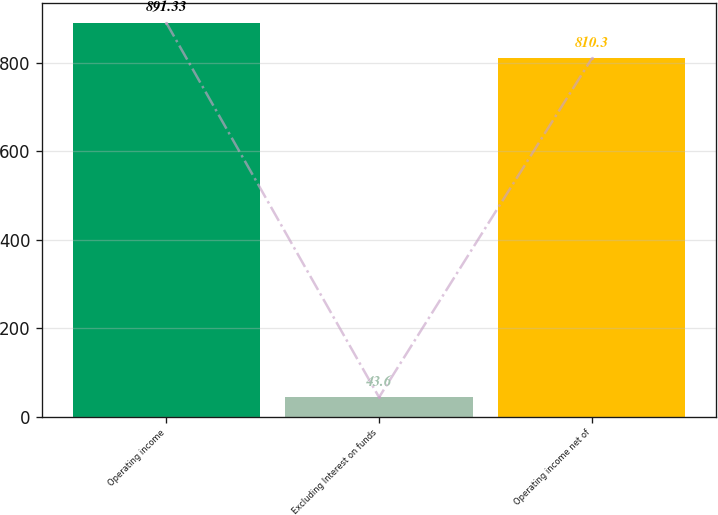Convert chart to OTSL. <chart><loc_0><loc_0><loc_500><loc_500><bar_chart><fcel>Operating income<fcel>Excluding Interest on funds<fcel>Operating income net of<nl><fcel>891.33<fcel>43.6<fcel>810.3<nl></chart> 